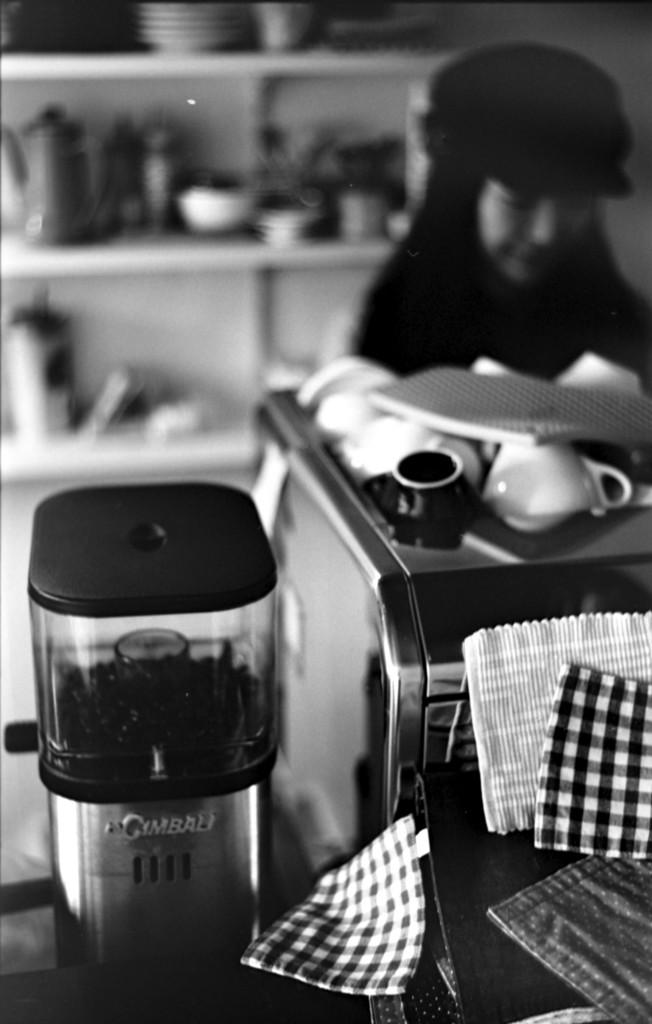What brand is the silver appliance?
Ensure brevity in your answer.  Gimbali. 